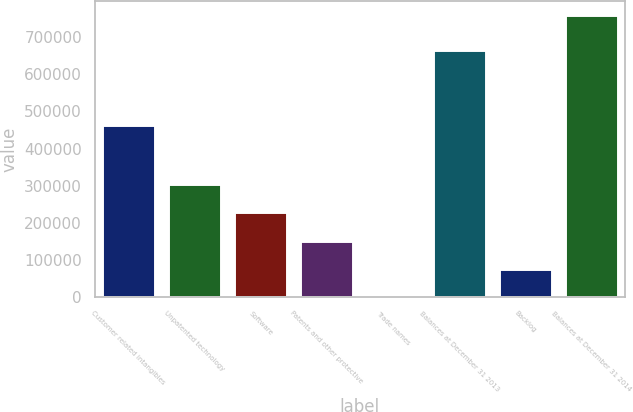Convert chart. <chart><loc_0><loc_0><loc_500><loc_500><bar_chart><fcel>Customer related intangibles<fcel>Unpatented technology<fcel>Software<fcel>Patents and other protective<fcel>Trade names<fcel>Balances at December 31 2013<fcel>Backlog<fcel>Balances at December 31 2014<nl><fcel>464018<fcel>304017<fcel>228017<fcel>152016<fcel>16<fcel>664131<fcel>76016.2<fcel>760018<nl></chart> 